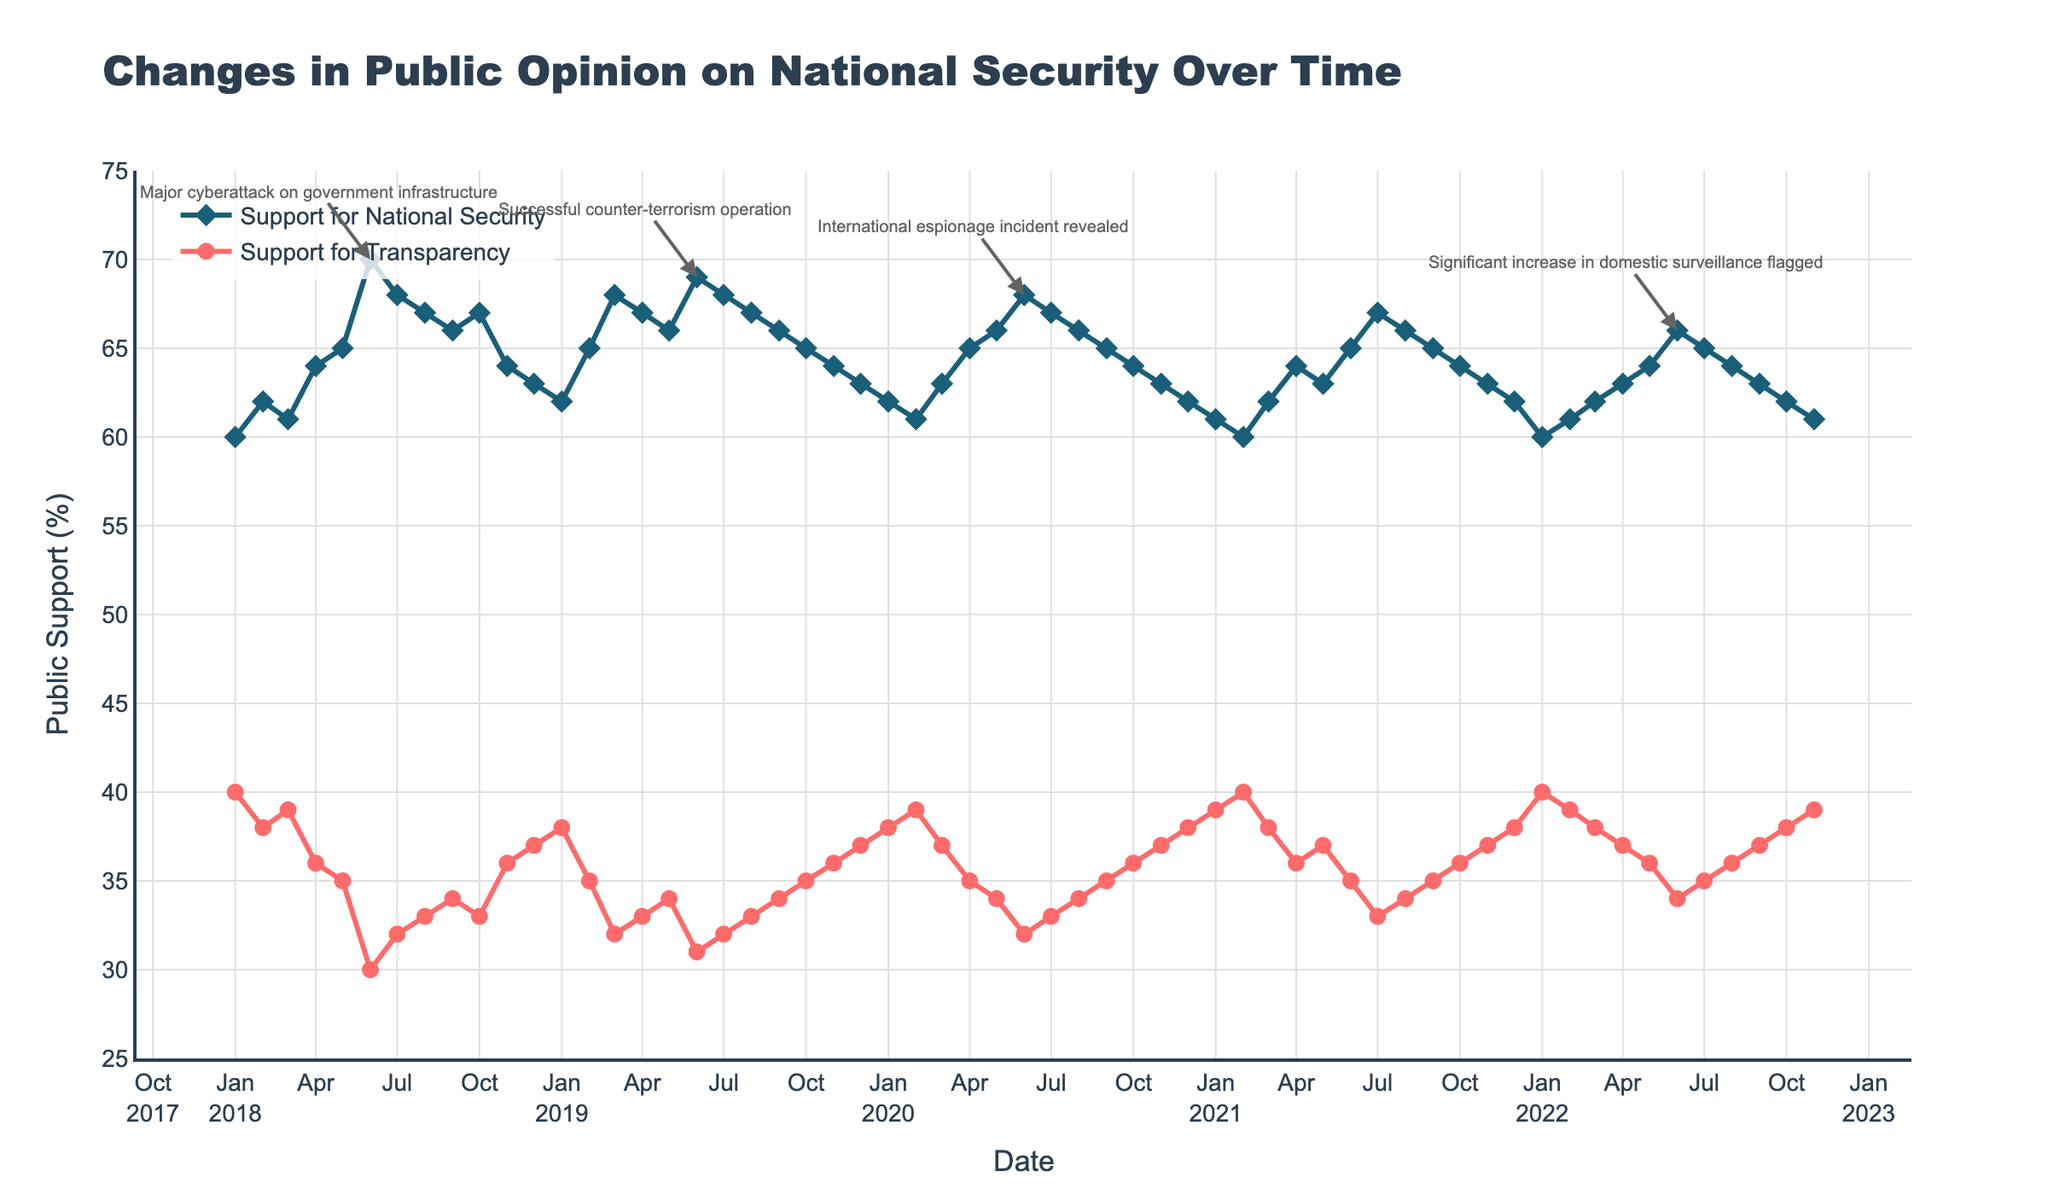What is the title of the figure? The title is usually at the top of the figure and describes the main topic. In this case, it is clearly displayed at the top as the main heading.
Answer: Changes in Public Opinion on National Security Over Time What is the highest level of public support for national security measures, and when did it occur? Look for the highest point on the line representing public support for national security measures, and then identify the corresponding date from the x-axis.
Answer: 70% in June 2018 How did the major cyberattack in June 2018 affect public opinion on national security and transparency measures? Look at the values before and after June 2018 to see the trend in public support for both national security and transparency measures. Notice the change in the supporting percentages.
Answer: Increased for national security, decreased for transparency Which event had a more significant impact on public opinion on national security measures: the major cyberattack in June 2018 or the successful counter-terrorism operation in June 2019? Compare the changes in the support for national security measures before and after both events. Assess which event leads to a more considerable change in the public opinion.
Answer: Major cyberattack in June 2018 What trend can you observe in public support for transparency measures from January 2018 to November 2022? Follow the line representing public support for transparency measures from the start to the end of the plotted timeline. Note any consistent increase, decrease, or stability in the values.
Answer: Gradual decline What was the level of public support for transparency measures exactly one year after the major cyberattack in June 2018? Find the value of public support for transparency measures in June 2019, which is one year after the major cyberattack.
Answer: 31% How did the public's support for national security measures change from June 2020 to July 2020, following the international espionage incident? Compare the values of public support for national security measures in June 2020 and July 2020 to note any increase, decrease, or stability.
Answer: Decreased from 68% to 67% Is there any point in time where public support for national security and transparency measures were equal? Look for any point where the two lines representing public support for national security and transparency measures intersect.
Answer: No How does the public support for transparency measures in November 2022 compare to that in January 2018? Compare the values of public support for transparency measures at the two dates to see if there was an increase, decrease, or if it stayed the same.
Answer: Stayed the same at 40% What is the median value of public support for national security measures across the entire period? Arrange all data points of public support for national security measures in ascending order and find the middle value since it's a median.
Answer: 65% 